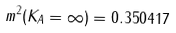<formula> <loc_0><loc_0><loc_500><loc_500>m ^ { 2 } ( K _ { A } = \infty ) = 0 . 3 5 0 4 1 7</formula> 